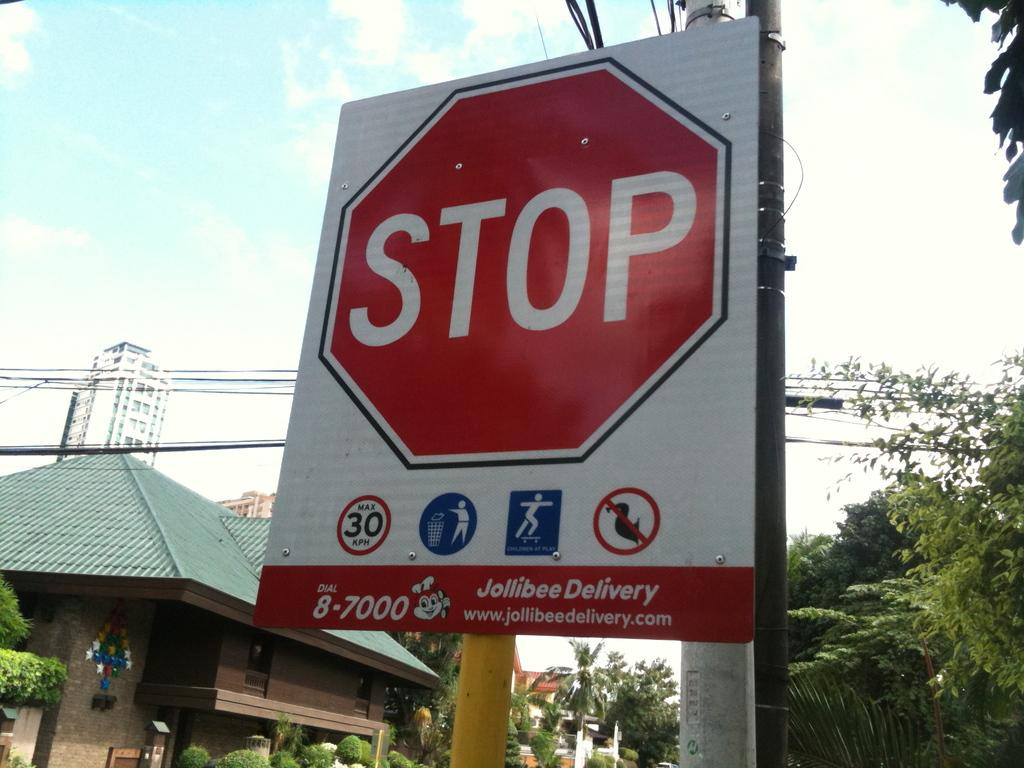<image>
Summarize the visual content of the image. A stop sign with Jollibee Delivery printed under it. 